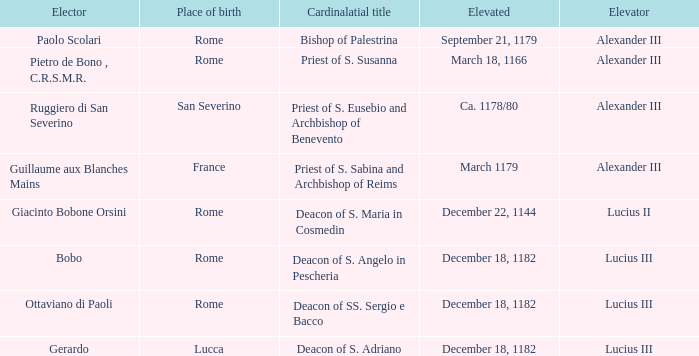What Elector was Elevated on December 18, 1182? Bobo, Ottaviano di Paoli, Gerardo. 